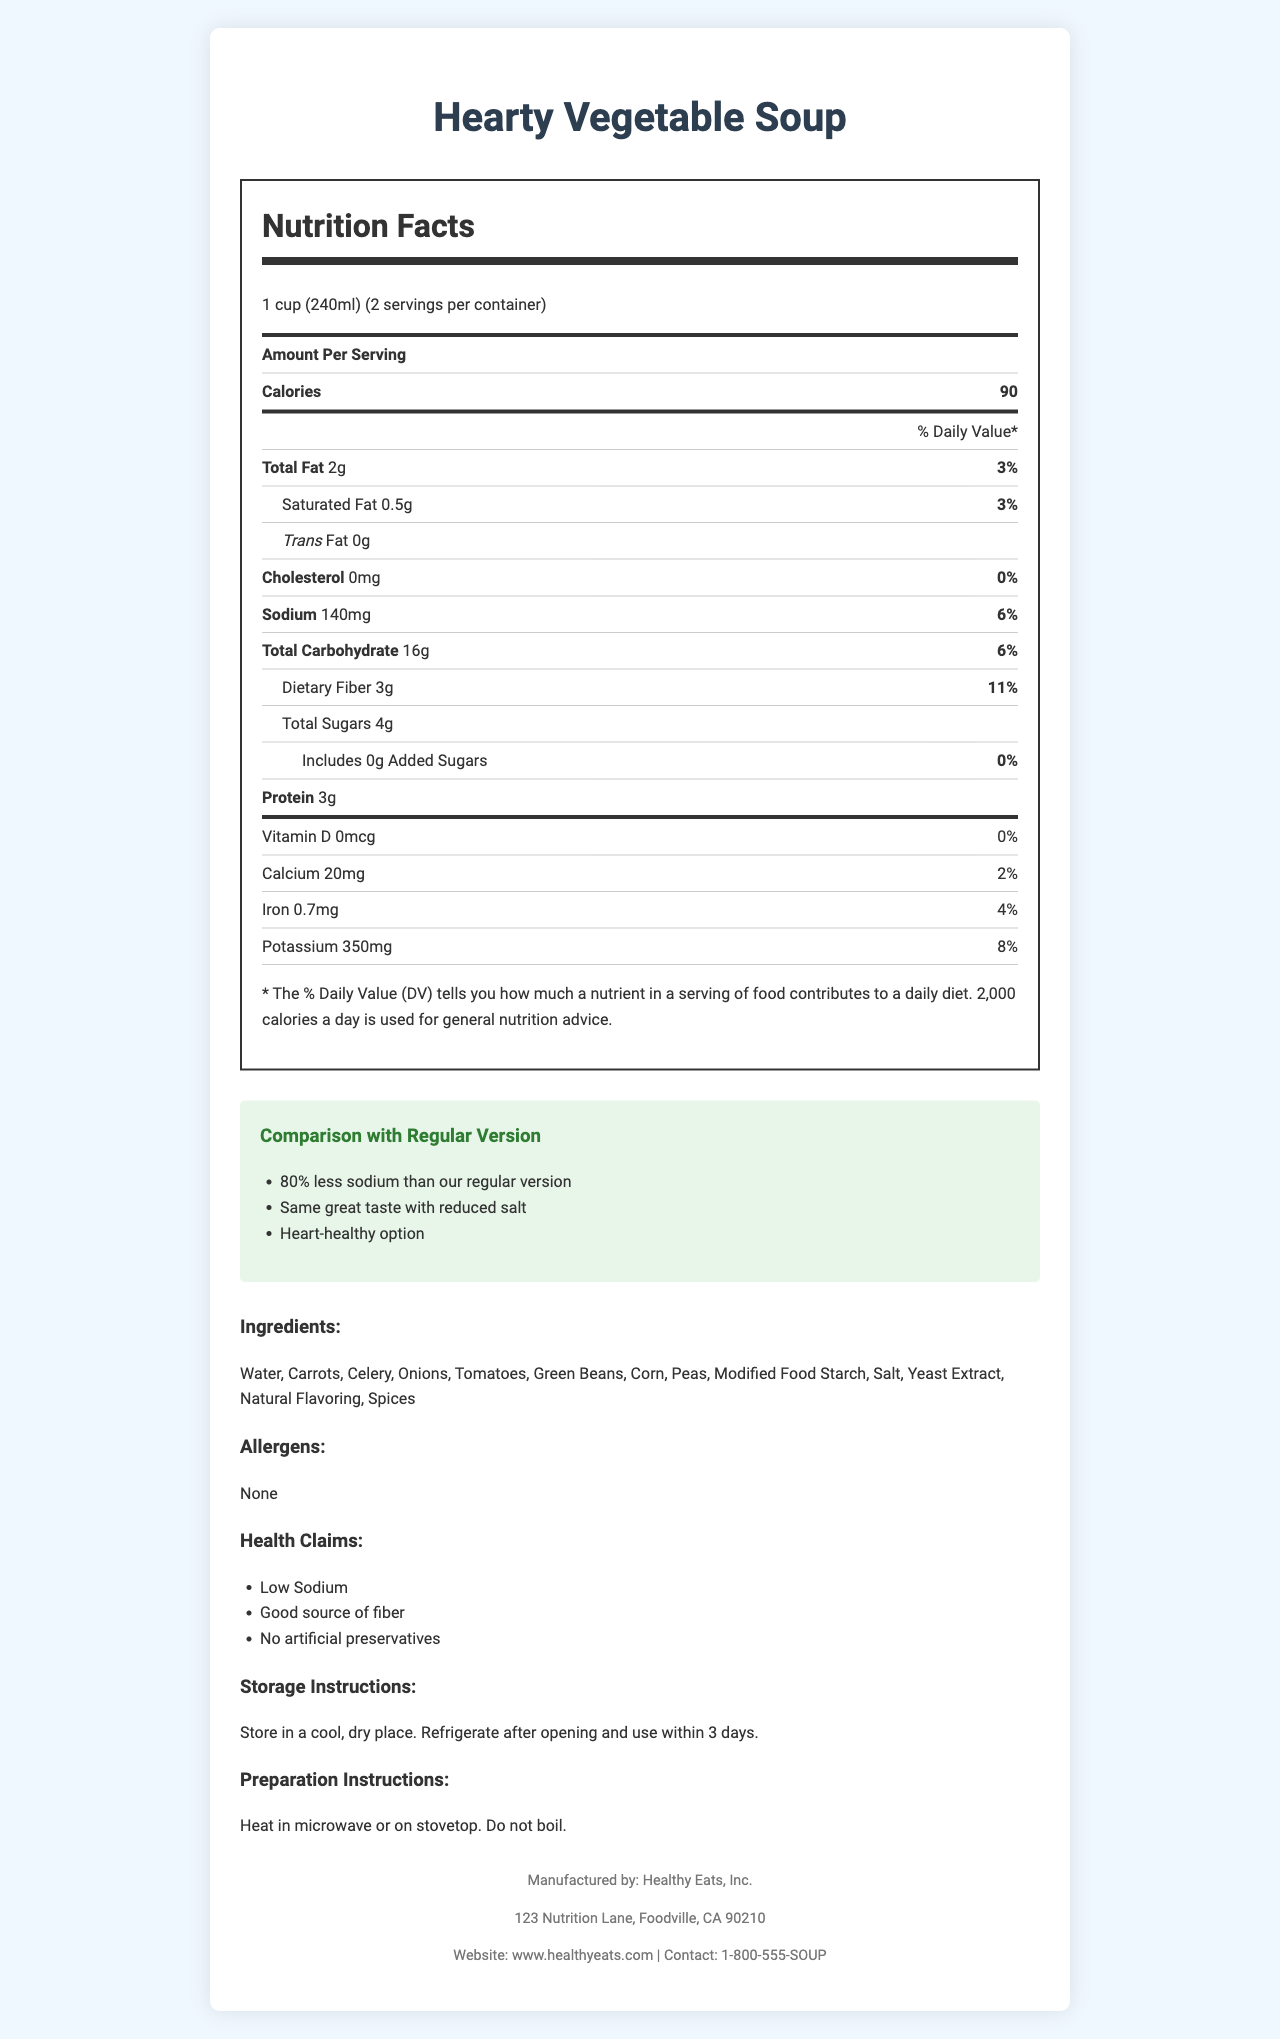what is the serving size of the Hearty Vegetable Soup? The document specifies that the serving size is 1 cup (240ml).
Answer: 1 cup (240ml) how many servings are there per container? The document states that there are 2 servings per container.
Answer: 2 how many calories are there per serving? According to the document, each serving contains 90 calories.
Answer: 90 what is the total sodium content in the low-sodium version? The sodium content in the low-sodium version is listed as 140mg.
Answer: 140mg which ingredient appears first on the ingredients list? The ingredients list starts with "Water."
Answer: Water what is the difference in sodium content between the low-sodium and regular versions? The regular version has 680mg of sodium, while the low-sodium version has 140mg. The difference is 680mg - 140mg = 540mg.
Answer: 540mg what are the health claims mentioned in the document? The document lists three health claims: Low Sodium, Good source of fiber, and No artificial preservatives.
Answer: Low Sodium, Good source of fiber, No artificial preservatives how much dietary fiber does the soup contain? The dietary fiber content is listed as 3g per serving.
Answer: 3g what is the daily value percentage for total fat in the soup? The document indicates that the total fat daily value percentage is 3%.
Answer: 3% what is the manufacturer's contact phone number? The manufacturer's contact phone number is listed as 1-800-555-SOUP.
Answer: 1-800-555-SOUP how much calcium is in one serving of the soup? The document states that each serving contains 20mg of calcium.
Answer: 20mg is this soup a good source of protein? The soup contains 3g of protein per serving but does not have any special claim about being a high source of protein.
Answer: No how should the soup be stored after opening? The storage instructions state to refrigerate after opening and use within 3 days.
Answer: Refrigerate and use within 3 days which of the following is not one of the soup's ingredients? A. Carrots, B. Potatoes, C. Celery, D. Tomatoes Potatoes are not listed in the ingredients while Carrots, Celery, and Tomatoes are.
Answer: B which nutrient does the soup contain more of in the regular version compared to the low-sodium version? A. Cholesterol, B. Sodium, C. Total Sugars, D. Iron Sodium is significantly higher in the regular version compared to the low-sodium version.
Answer: B does the soup contain any added sugars? The document indicates 0g of added sugars.
Answer: No summarize the document. The summary covers the content similarity, including nutritional information, claims, instructions, and manufacturer details.
Answer: The document is a nutrition facts label for Hearty Vegetable Soup, specifically highlighting a low-sodium version compared to the regular version. It provides detailed nutritional information per serving, including calories, fat, cholesterol, sodium, carbohydrates, fiber, sugars, protein, vitamins, and minerals. It also lists the ingredients, allergens, health claims, storage and preparation instructions, comparison highlights, and manufacturer information. what is the exact address of the manufacturer? The exact address is provided in the document, but since the question is unanswerable based on the visual document alone, it is marked as requiring more detailed insight from the document.
Answer: Cannot be determined 